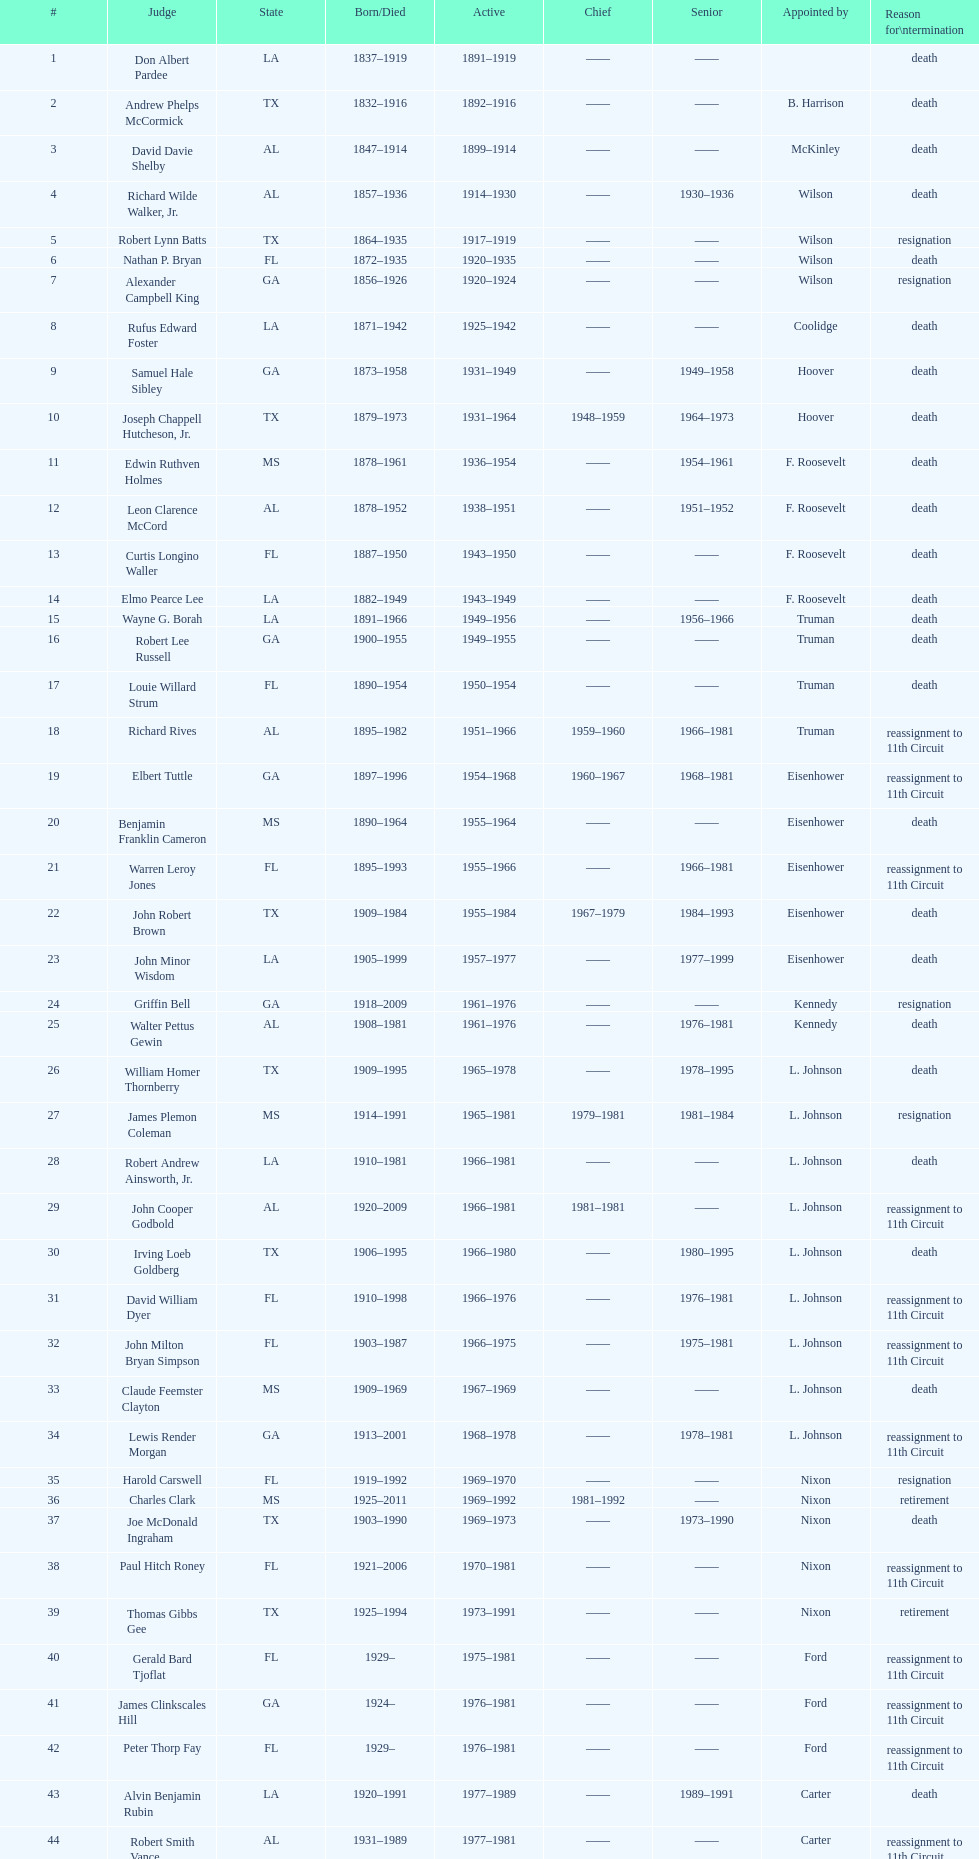In which state can the largest quantity of judges be found serving? TX. 